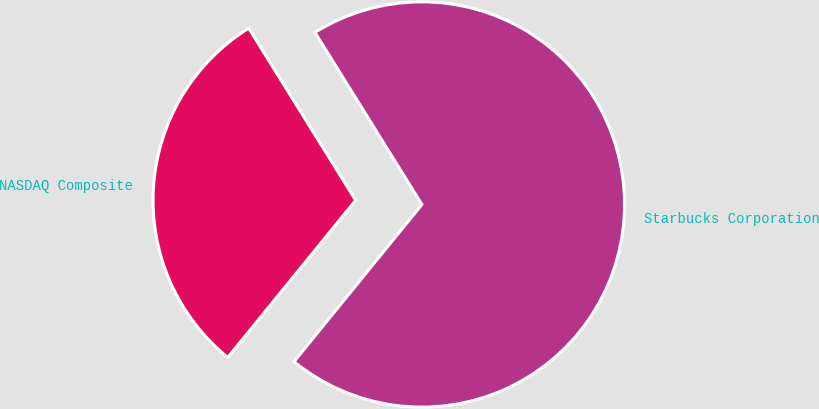Convert chart. <chart><loc_0><loc_0><loc_500><loc_500><pie_chart><fcel>Starbucks Corporation<fcel>NASDAQ Composite<nl><fcel>69.72%<fcel>30.28%<nl></chart> 